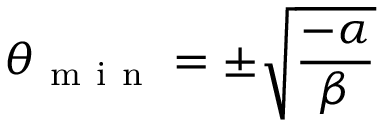Convert formula to latex. <formula><loc_0><loc_0><loc_500><loc_500>\theta _ { m i n } = \pm \sqrt { \frac { - \alpha } { \beta } }</formula> 